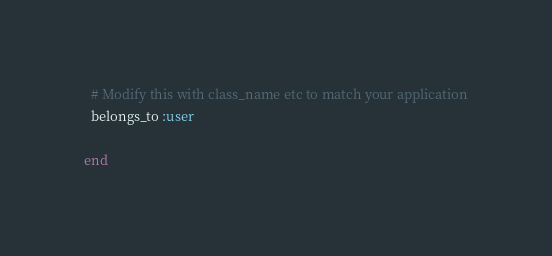Convert code to text. <code><loc_0><loc_0><loc_500><loc_500><_Ruby_>
  # Modify this with class_name etc to match your application
  belongs_to :user

end
</code> 